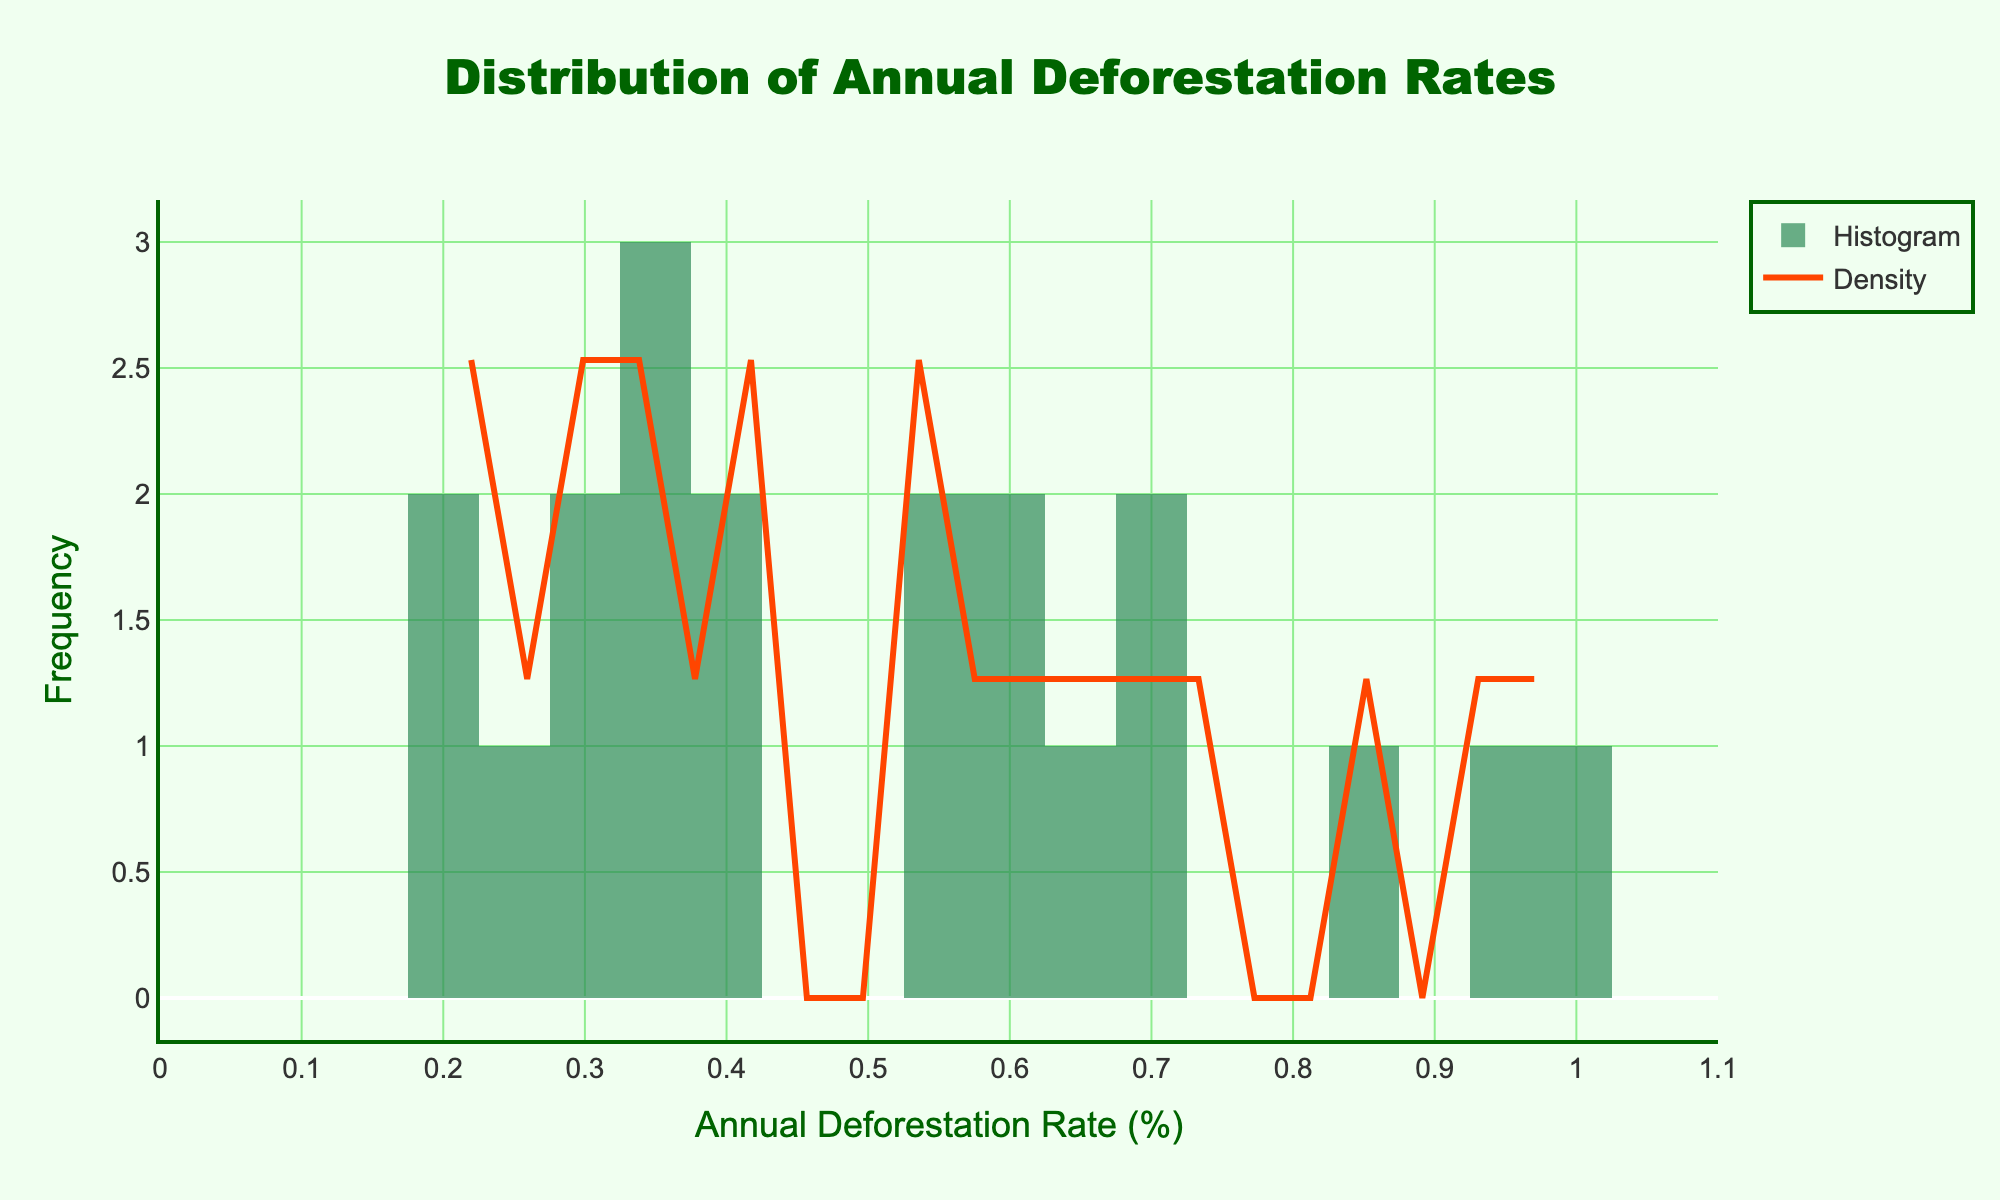What is the title of the figure? The title of the figure is located at the top and reads "Distribution of Annual Deforestation Rates".
Answer: Distribution of Annual Deforestation Rates What is the x-axis label of the histogram? The x-axis label is at the bottom of the figure and reads "Annual Deforestation Rate (%)".
Answer: Annual Deforestation Rate (%) What is the y-axis label of the histogram? The y-axis label is on the left side of the figure and reads "Frequency".
Answer: Frequency Which data point has the highest density according to the KDE curve? The highest point on the KDE curve indicates the highest density. From the graph, we can identify this peak around the 0.4% to 0.6% range.
Answer: 0.4% to 0.6% How does the color of the histogram bars compare to the KDE curve color? The histogram bars are green, while the KDE curve is orange, making them easily distinguishable.
Answer: The histogram bars are green, and the KDE curve is orange Which country has the highest annual deforestation rate according to the histogram data? According to the histogram data, the peak in the highest bin indicates the presence of Cambodia with a rate of 0.94%.
Answer: Cambodia Approximately how many countries have annual deforestation rates between 0.5% and 0.7%? To find the number of countries, observe the bars in the range of 0.5% to 0.7%. There are four bars indicating countries: Bolivia, Mozambique, Nigeria, and Zambia.
Answer: Four (4) What is the approximate range of annual deforestation rates shown in the histogram? The x-axis range shows the distribution starting from 0% extending right above 1%, indicating the approximate range.
Answer: 0% to slightly above 1% Which country has its deforestation rate closest to the highest density peak in the KDE curve? The highest density peak is around 0.4% to 0.6%. The rate closest to this peak is Brazil, with a rate of 0.42%.
Answer: Brazil 